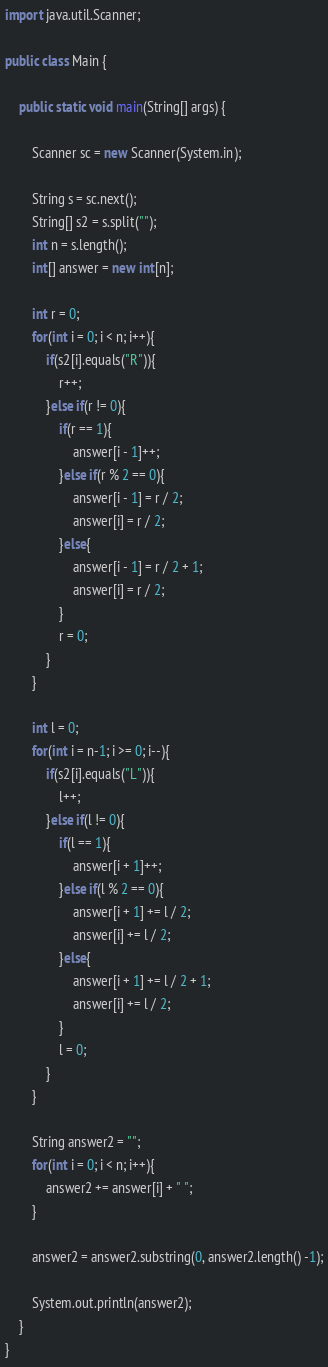Convert code to text. <code><loc_0><loc_0><loc_500><loc_500><_Java_>import java.util.Scanner;

public class Main {

    public static void main(String[] args) {
        
        Scanner sc = new Scanner(System.in);
        
        String s = sc.next();
        String[] s2 = s.split("");
        int n = s.length();
        int[] answer = new int[n];
        
        int r = 0;
        for(int i = 0; i < n; i++){
            if(s2[i].equals("R")){
                r++;
            }else if(r != 0){
                if(r == 1){
                    answer[i - 1]++;
                }else if(r % 2 == 0){
                    answer[i - 1] = r / 2;
                    answer[i] = r / 2;
                }else{
                    answer[i - 1] = r / 2 + 1;
                    answer[i] = r / 2;
                }
                r = 0;
            }
        }
        
        int l = 0;
        for(int i = n-1; i >= 0; i--){
            if(s2[i].equals("L")){
                l++;
            }else if(l != 0){
                if(l == 1){
                    answer[i + 1]++;
                }else if(l % 2 == 0){
                    answer[i + 1] += l / 2;
                    answer[i] += l / 2;
                }else{
                    answer[i + 1] += l / 2 + 1;
                    answer[i] += l / 2;
                }
                l = 0;
            }
        }
        
        String answer2 = "";
        for(int i = 0; i < n; i++){
            answer2 += answer[i] + " ";
        }
        
        answer2 = answer2.substring(0, answer2.length() -1);
        
        System.out.println(answer2);
    }
}</code> 